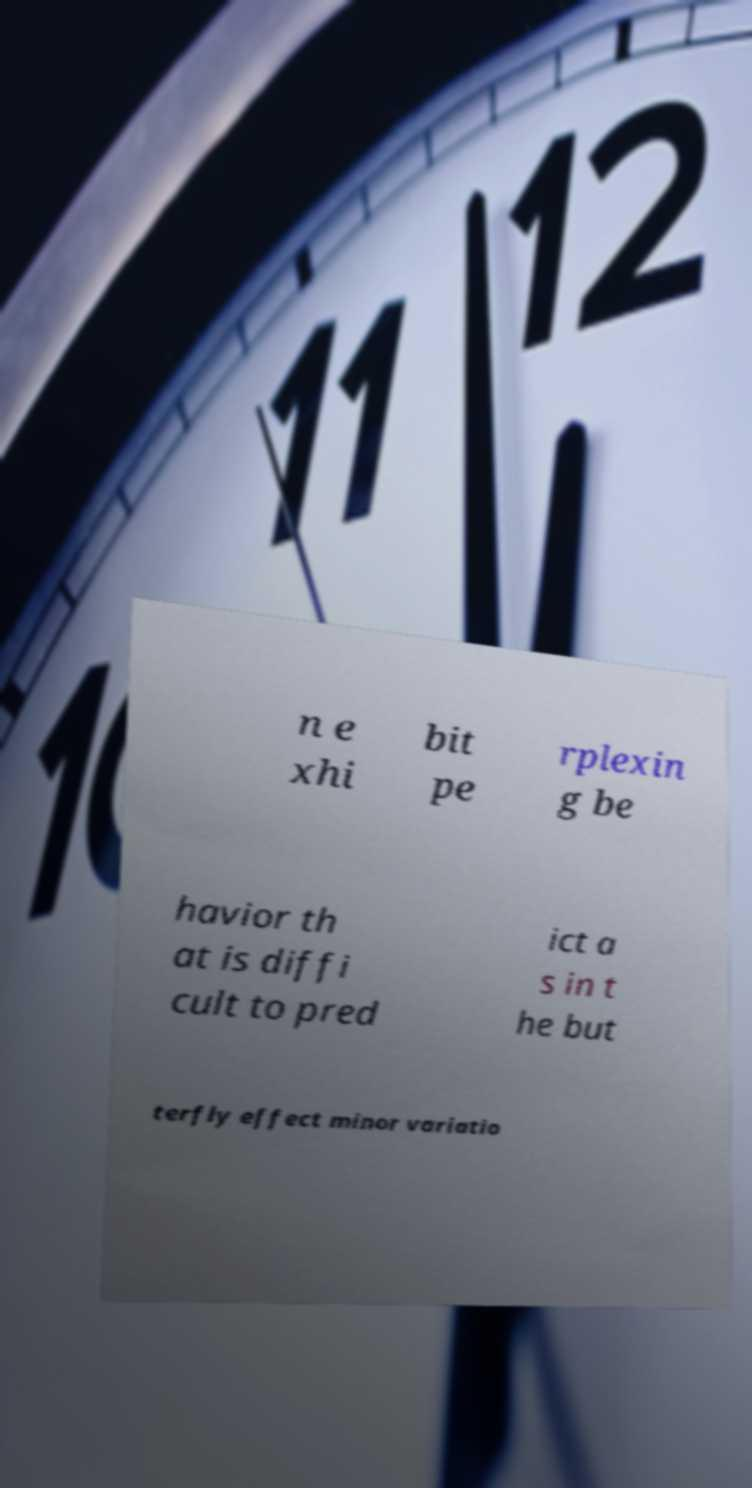Please identify and transcribe the text found in this image. n e xhi bit pe rplexin g be havior th at is diffi cult to pred ict a s in t he but terfly effect minor variatio 